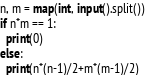Convert code to text. <code><loc_0><loc_0><loc_500><loc_500><_Python_>n, m = map(int, input().split())
if n*m == 1:
  print(0)
else:
  print(n*(n-1)/2+m*(m-1)/2)</code> 